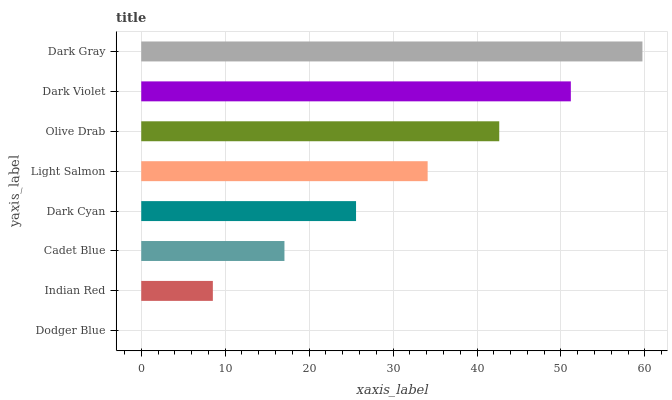Is Dodger Blue the minimum?
Answer yes or no. Yes. Is Dark Gray the maximum?
Answer yes or no. Yes. Is Indian Red the minimum?
Answer yes or no. No. Is Indian Red the maximum?
Answer yes or no. No. Is Indian Red greater than Dodger Blue?
Answer yes or no. Yes. Is Dodger Blue less than Indian Red?
Answer yes or no. Yes. Is Dodger Blue greater than Indian Red?
Answer yes or no. No. Is Indian Red less than Dodger Blue?
Answer yes or no. No. Is Light Salmon the high median?
Answer yes or no. Yes. Is Dark Cyan the low median?
Answer yes or no. Yes. Is Olive Drab the high median?
Answer yes or no. No. Is Dodger Blue the low median?
Answer yes or no. No. 